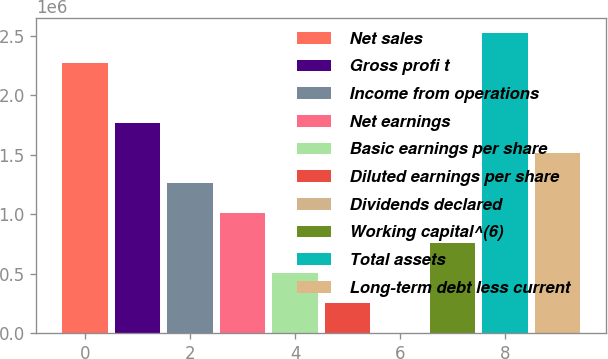Convert chart. <chart><loc_0><loc_0><loc_500><loc_500><bar_chart><fcel>Net sales<fcel>Gross profi t<fcel>Income from operations<fcel>Net earnings<fcel>Basic earnings per share<fcel>Diluted earnings per share<fcel>Dividends declared<fcel>Working capital^(6)<fcel>Total assets<fcel>Long-term debt less current<nl><fcel>2.27008e+06<fcel>1.76561e+06<fcel>1.26115e+06<fcel>1.00892e+06<fcel>504461<fcel>252231<fcel>0.22<fcel>756692<fcel>2.52231e+06<fcel>1.51338e+06<nl></chart> 